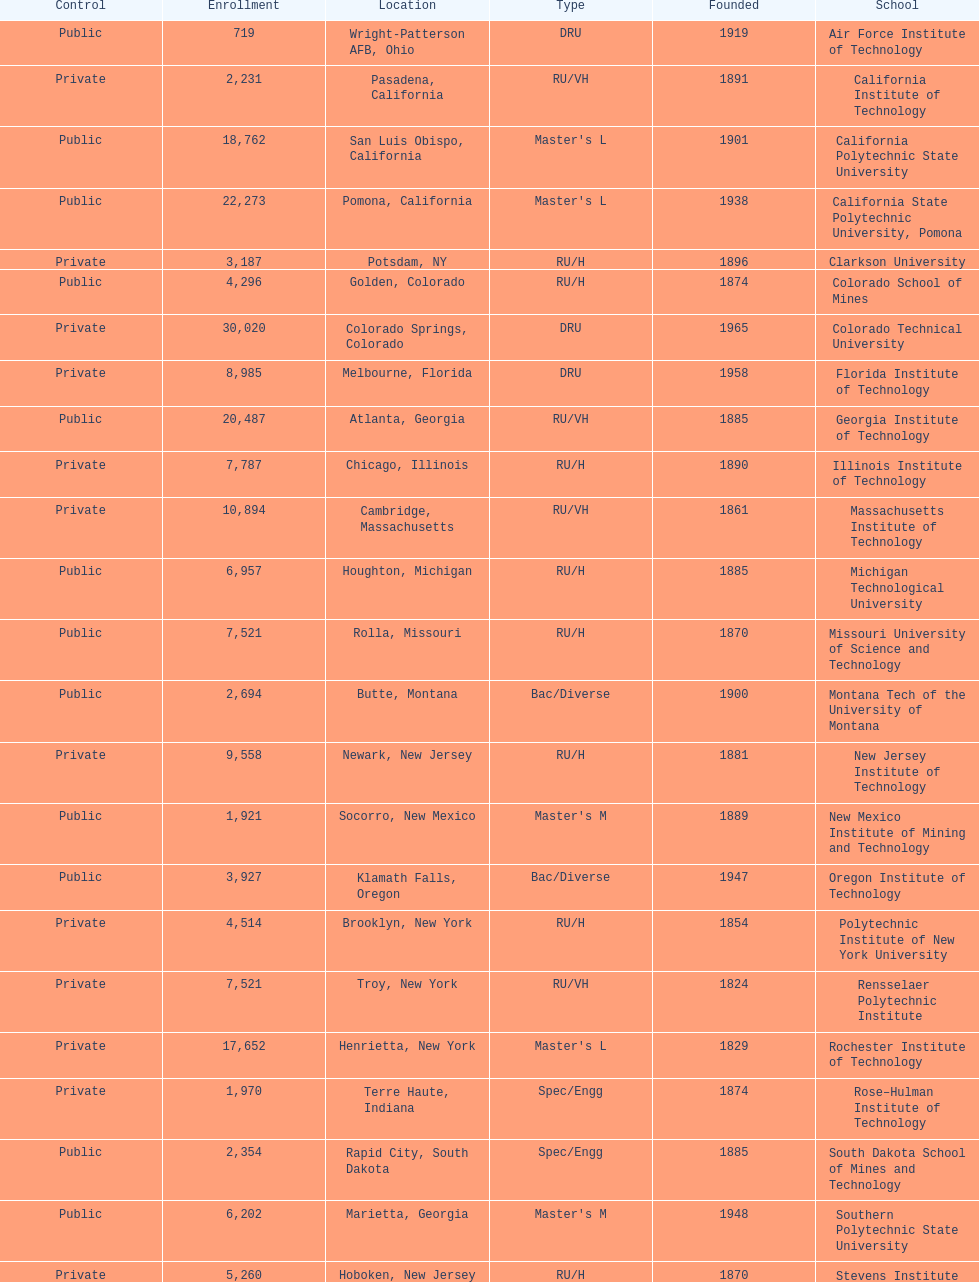Which us technological institute has the highest enrollment figures? Texas Tech University. 